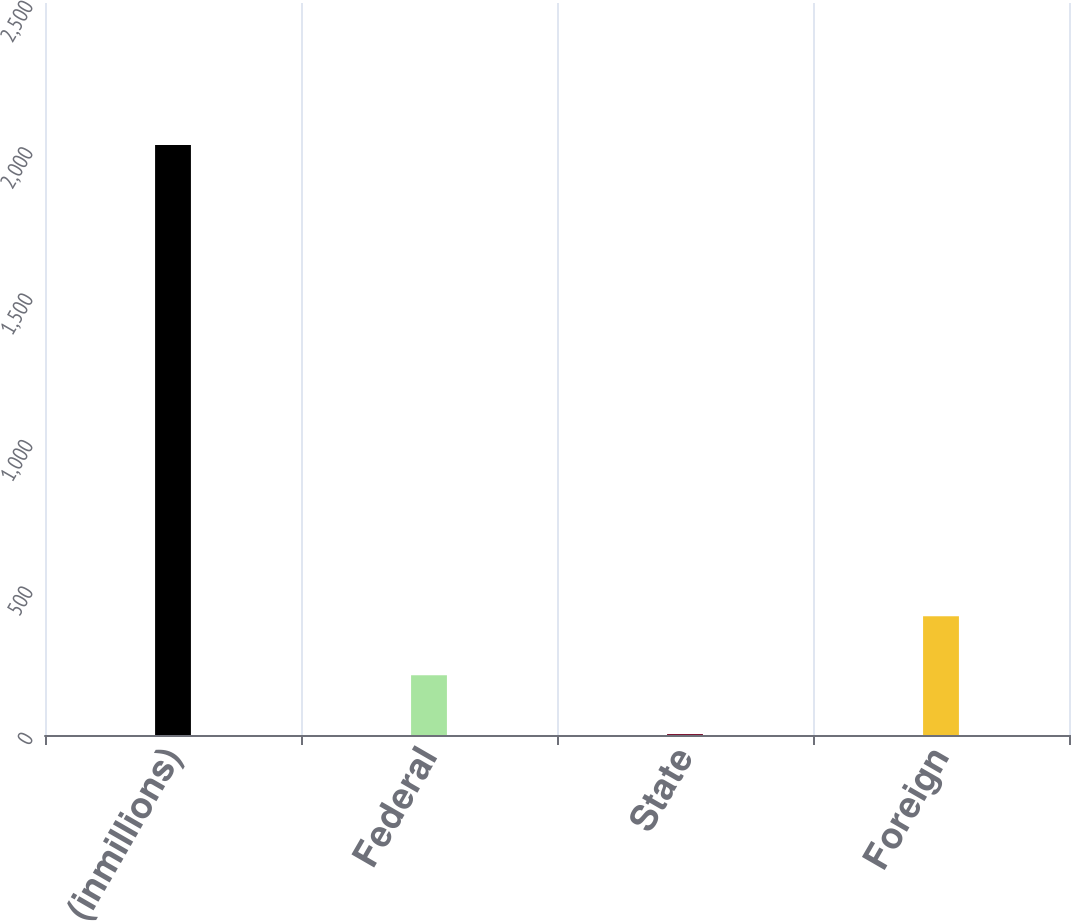<chart> <loc_0><loc_0><loc_500><loc_500><bar_chart><fcel>(inmillions)<fcel>Federal<fcel>State<fcel>Foreign<nl><fcel>2015<fcel>204.2<fcel>3<fcel>405.4<nl></chart> 